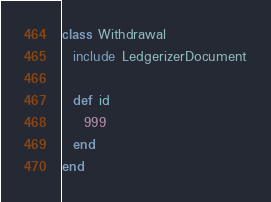Convert code to text. <code><loc_0><loc_0><loc_500><loc_500><_Ruby_>class Withdrawal
  include LedgerizerDocument

  def id
    999
  end
end
</code> 